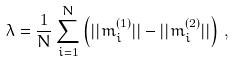Convert formula to latex. <formula><loc_0><loc_0><loc_500><loc_500>\lambda = \frac { 1 } { N } \sum _ { i = 1 } ^ { N } \left ( | | m ^ { ( 1 ) } _ { i } | | - | | m ^ { ( 2 ) } _ { i } | | \right ) \, ,</formula> 